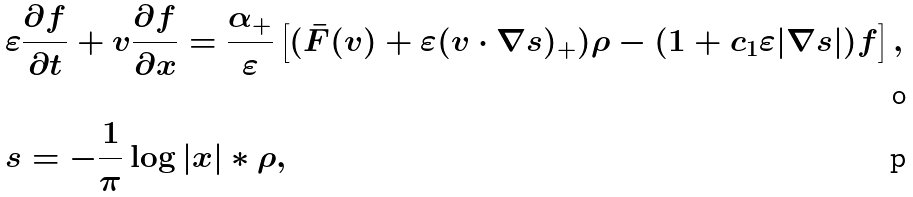Convert formula to latex. <formula><loc_0><loc_0><loc_500><loc_500>& \varepsilon \frac { \partial f } { \partial t } + v \frac { \partial f } { \partial x } = \frac { \alpha _ { + } } { \varepsilon } \left [ ( \bar { F } ( v ) + \varepsilon ( v \cdot \nabla s ) _ { + } ) \rho - ( 1 + c _ { 1 } \varepsilon | \nabla s | ) f \right ] , \\ & s = - \frac { 1 } { \pi } \log | x | \ast \rho ,</formula> 